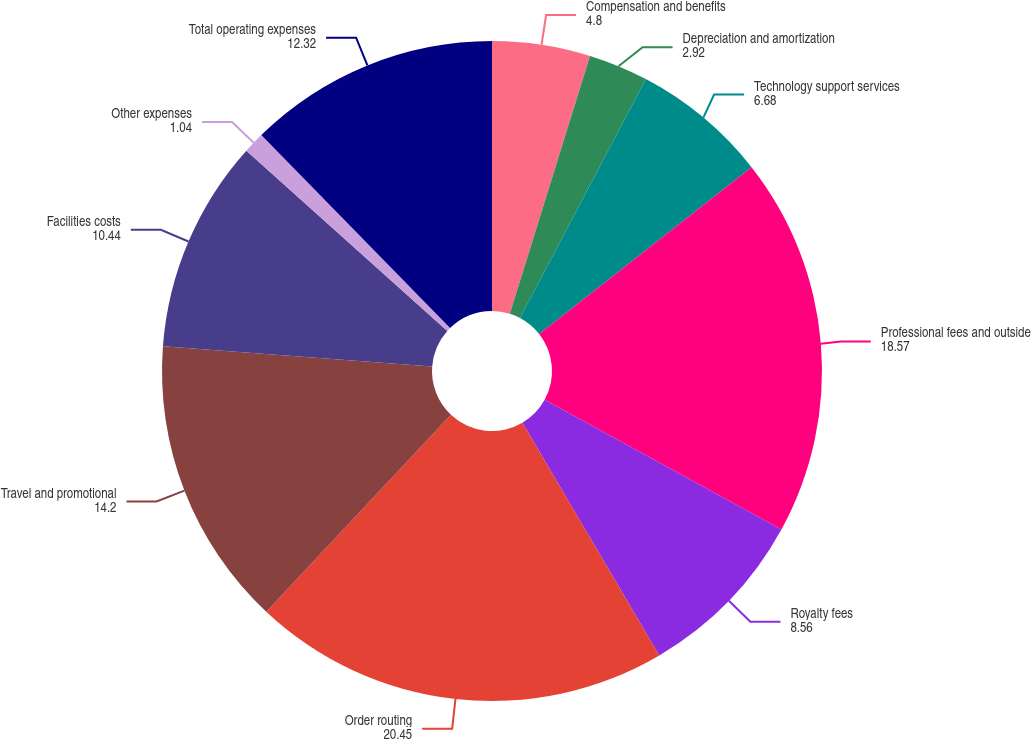Convert chart to OTSL. <chart><loc_0><loc_0><loc_500><loc_500><pie_chart><fcel>Compensation and benefits<fcel>Depreciation and amortization<fcel>Technology support services<fcel>Professional fees and outside<fcel>Royalty fees<fcel>Order routing<fcel>Travel and promotional<fcel>Facilities costs<fcel>Other expenses<fcel>Total operating expenses<nl><fcel>4.8%<fcel>2.92%<fcel>6.68%<fcel>18.57%<fcel>8.56%<fcel>20.45%<fcel>14.2%<fcel>10.44%<fcel>1.04%<fcel>12.32%<nl></chart> 